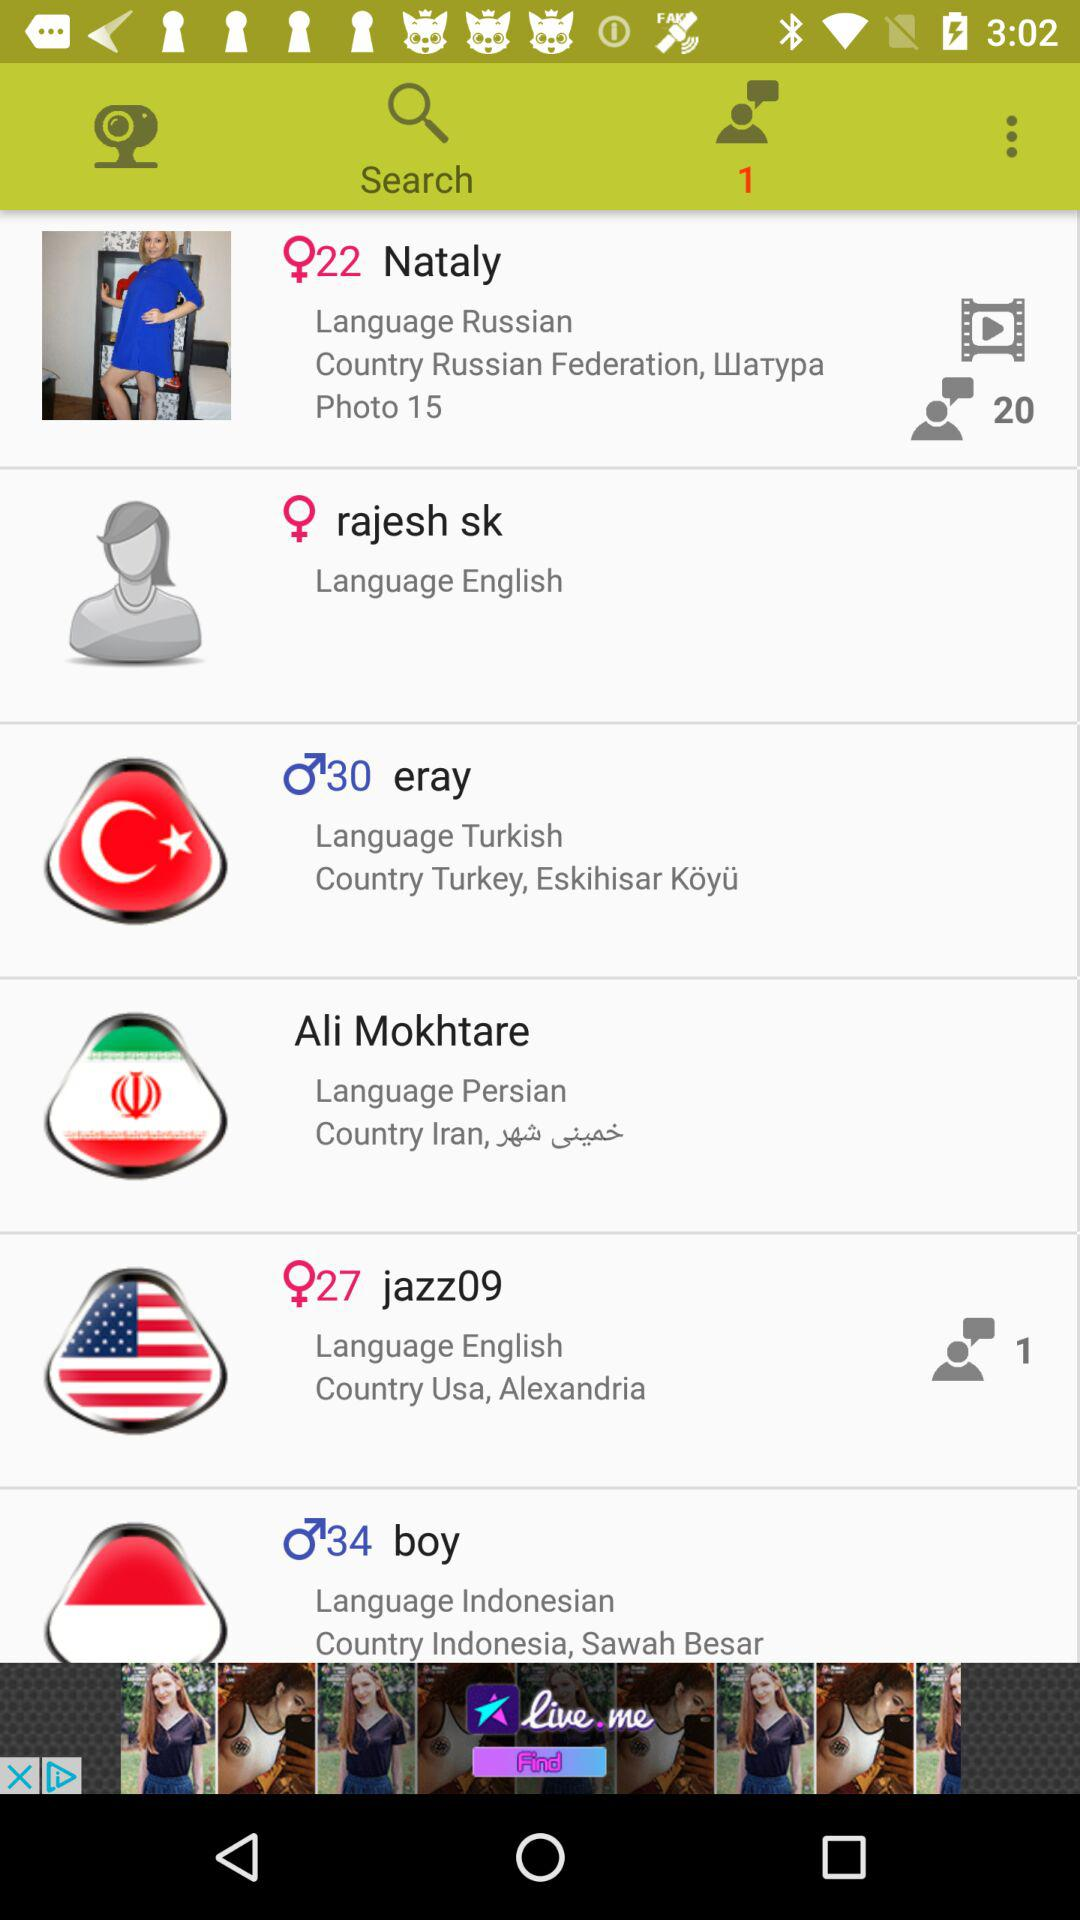How many new message requests are there for user "jazz09"? There is 1 new message request for user "jazz09". 